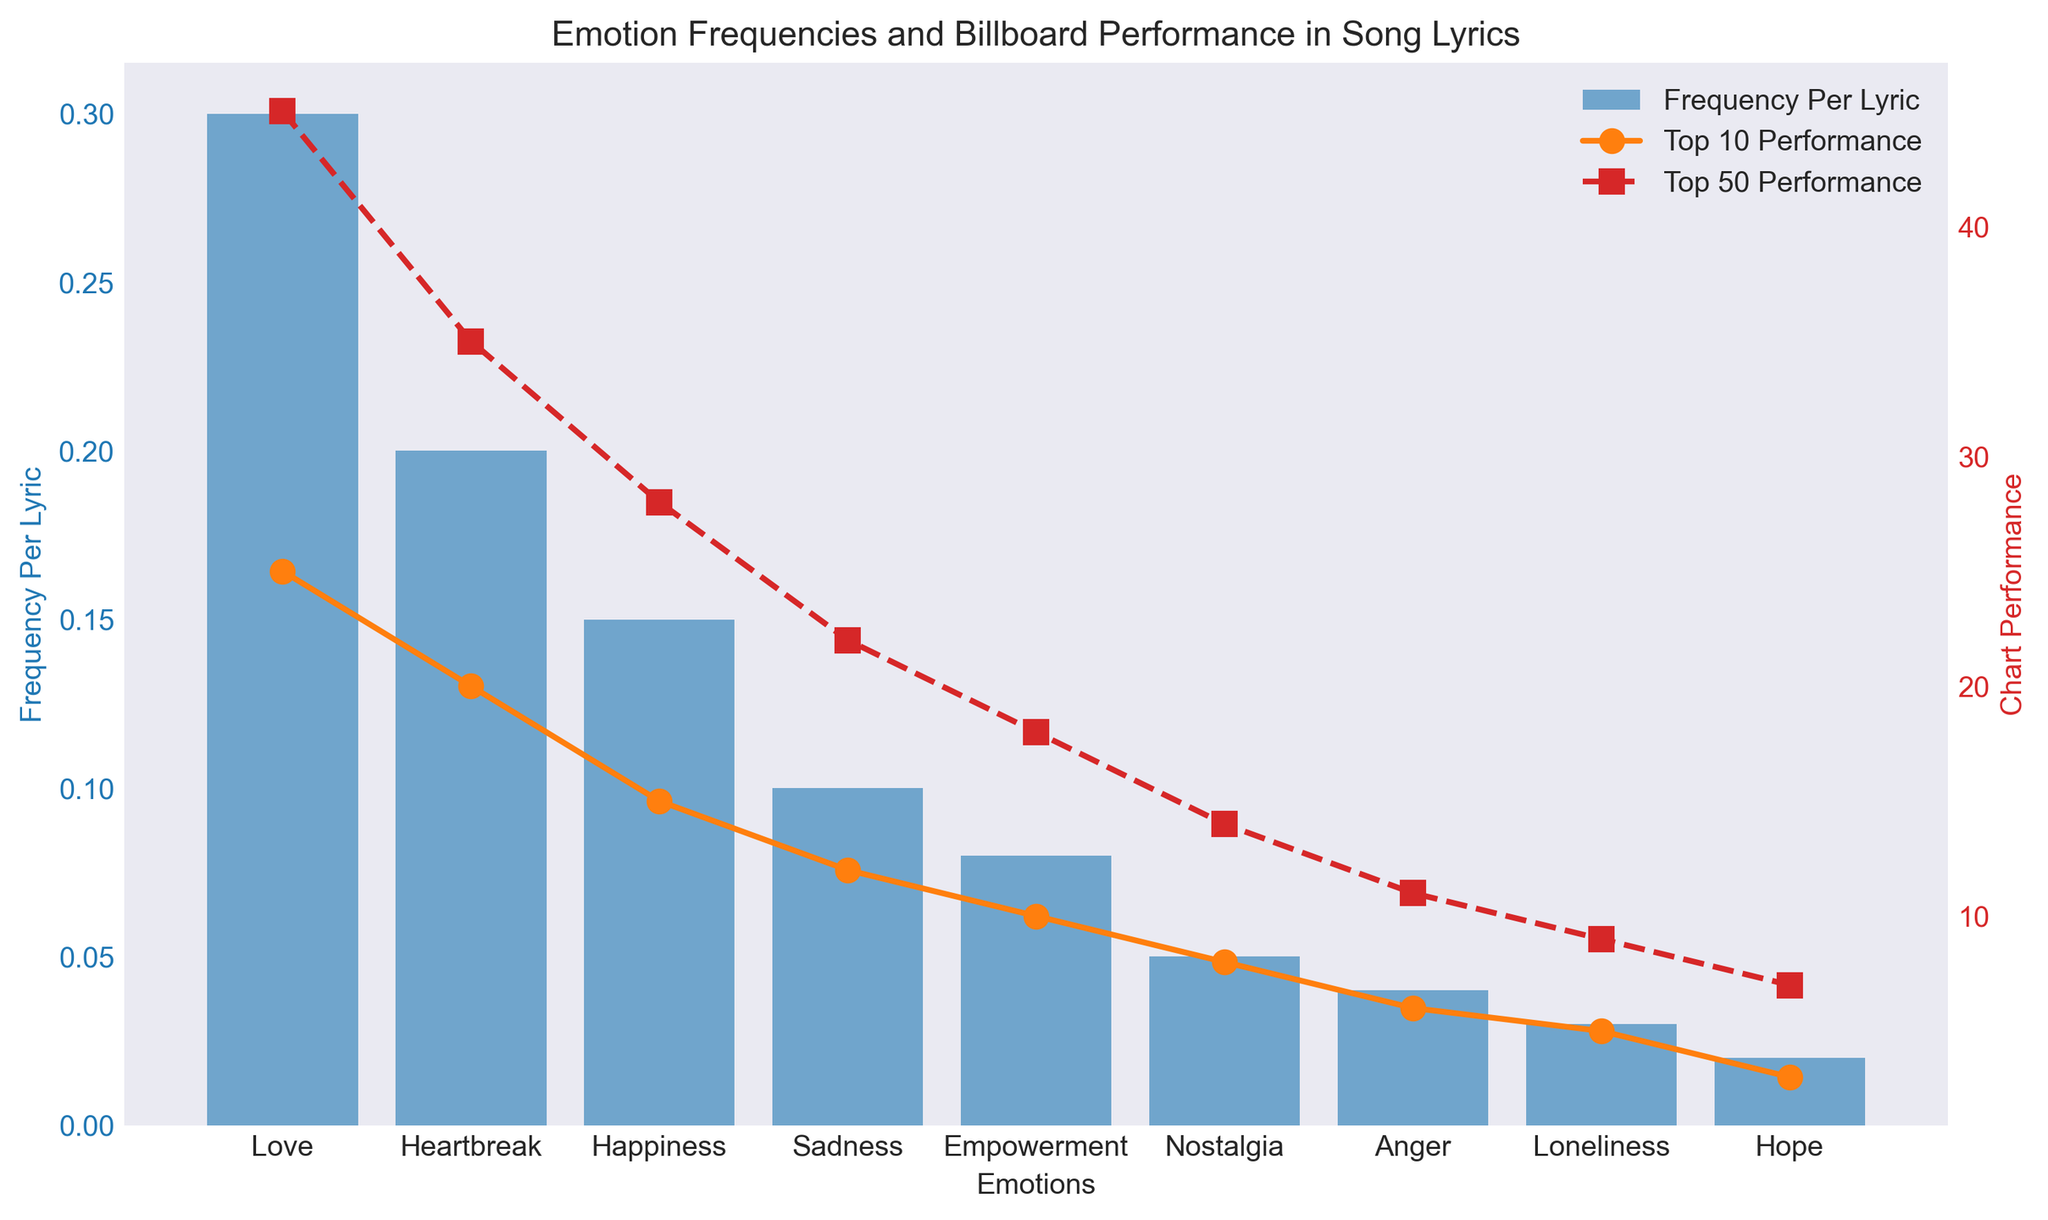What is the most frequent emotion in song lyrics according to the chart? The blue bars represent the frequency per lyric. The highest bar corresponds to the emotion "Love".
Answer: Love Which emotions have a frequency per lyric greater than 0.1? By checking the height of the blue bars, the emotions with bars taller than the 0.1 mark are "Love", "Heartbreak", and "Happiness".
Answer: Love, Heartbreak, Happiness Which emotion has the highest Top 10 chart performance? The orange line with circle markers shows the Top 10 performance. The highest point on this line corresponds to the emotion "Love".
Answer: Love Comparing "Anger" and "Sadness", which one has a higher frequency per lyric? The height of the blue bars for "Sadness" and "Anger" should be compared. "Sadness" has a higher blue bar than "Anger".
Answer: Sadness How much higher is the Top 10 performance of "Love" compared to "Hope"? The orange circle for "Love" is at 25, and for "Hope" it is at 3. The difference is 25 - 3.
Answer: 22 What is the difference in Top 50 performance between "Heartbreak" and "Nostalgia"? The red square for "Heartbreak" is at 35, and for "Nostalgia" it is at 14. The difference is 35 - 14.
Answer: 21 What is the combined Top 50 performance of "Heartbreak" and "Empowerment"? The red squares for "Heartbreak" and "Empowerment" are at 35 and 18 respectively. Summing them up gives 35 + 18.
Answer: 53 Which emotion has the lowest frequency per lyric? The shortest blue bar represents the lowest frequency per lyric. The shortest bar corresponds to the emotion "Hope".
Answer: Hope How does the frequency per lyric of "Happiness" compare to "Loneliness"? The height of the blue bar for "Happiness" is higher compared to the bar for "Loneliness".
Answer: Higher Comparing Top 10 and Top 50 performances, which is generally higher for each emotion? The red squares (Top 50) are higher than the orange circles (Top 10) for each emotion listed in the chart, indicating higher Top 50 performances.
Answer: Top 50 performance is higher for each emotion 